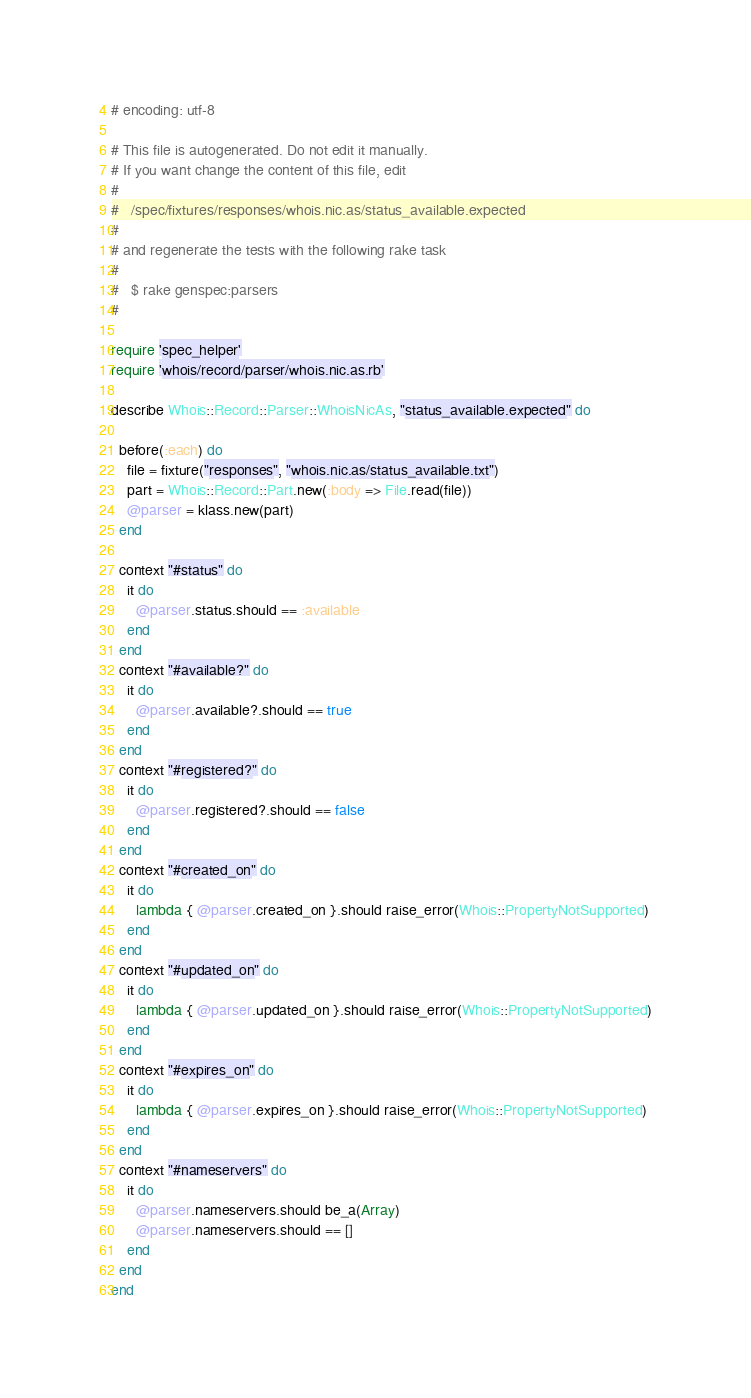Convert code to text. <code><loc_0><loc_0><loc_500><loc_500><_Ruby_># encoding: utf-8

# This file is autogenerated. Do not edit it manually.
# If you want change the content of this file, edit
#
#   /spec/fixtures/responses/whois.nic.as/status_available.expected
#
# and regenerate the tests with the following rake task
#
#   $ rake genspec:parsers
#

require 'spec_helper'
require 'whois/record/parser/whois.nic.as.rb'

describe Whois::Record::Parser::WhoisNicAs, "status_available.expected" do

  before(:each) do
    file = fixture("responses", "whois.nic.as/status_available.txt")
    part = Whois::Record::Part.new(:body => File.read(file))
    @parser = klass.new(part)
  end

  context "#status" do
    it do
      @parser.status.should == :available
    end
  end
  context "#available?" do
    it do
      @parser.available?.should == true
    end
  end
  context "#registered?" do
    it do
      @parser.registered?.should == false
    end
  end
  context "#created_on" do
    it do
      lambda { @parser.created_on }.should raise_error(Whois::PropertyNotSupported)
    end
  end
  context "#updated_on" do
    it do
      lambda { @parser.updated_on }.should raise_error(Whois::PropertyNotSupported)
    end
  end
  context "#expires_on" do
    it do
      lambda { @parser.expires_on }.should raise_error(Whois::PropertyNotSupported)
    end
  end
  context "#nameservers" do
    it do
      @parser.nameservers.should be_a(Array)
      @parser.nameservers.should == []
    end
  end
end
</code> 